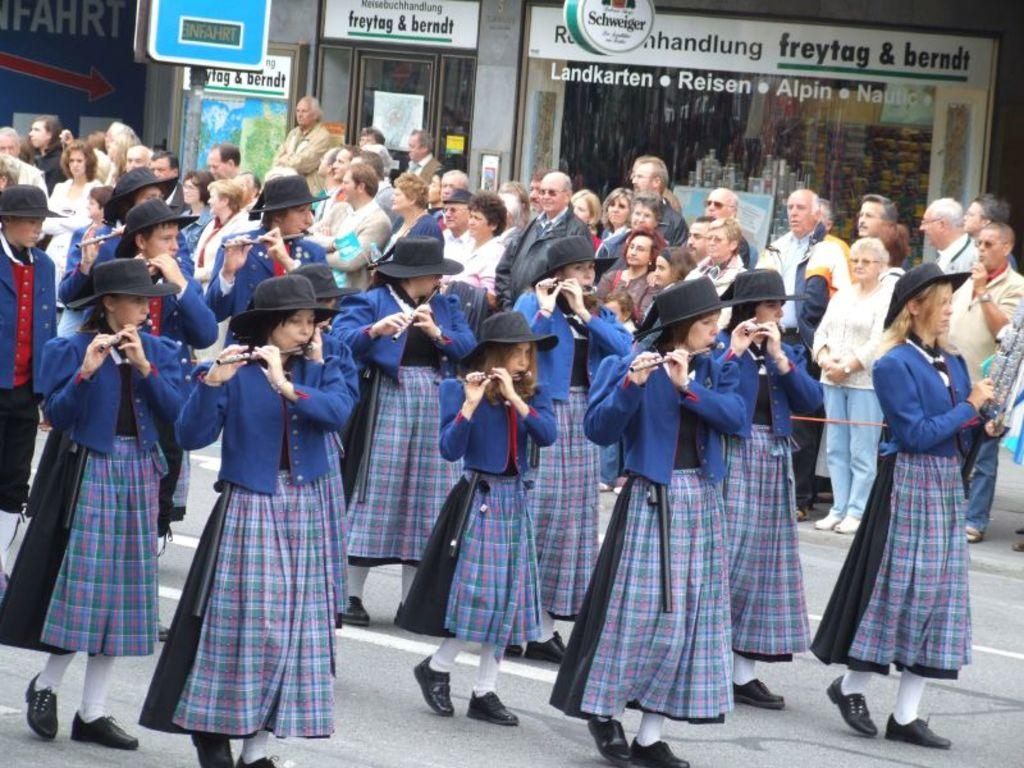What are the people in the image wearing? The persons in the image are wearing clothes. What are some of the persons doing in the image? Some persons are playing musical instruments. What type of architectural feature can be seen at the top of the image? There is a glass wall at the top of the image. What type of flowers can be seen growing on the stage in the image? There is no stage or flowers present in the image. 